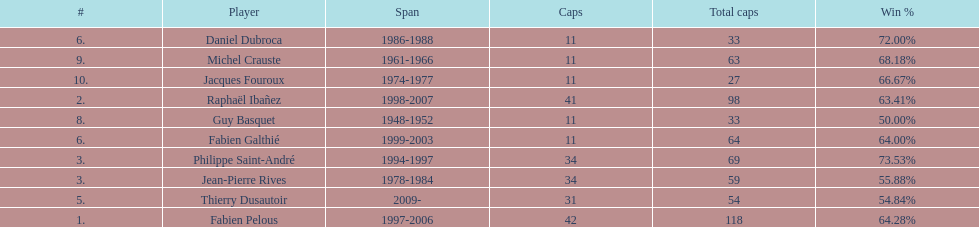Only player to serve as captain from 1998-2007 Raphaël Ibañez. 